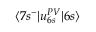Convert formula to latex. <formula><loc_0><loc_0><loc_500><loc_500>\langle 7 s ^ { - } | u _ { 6 s } ^ { P V } | 6 s \rangle</formula> 